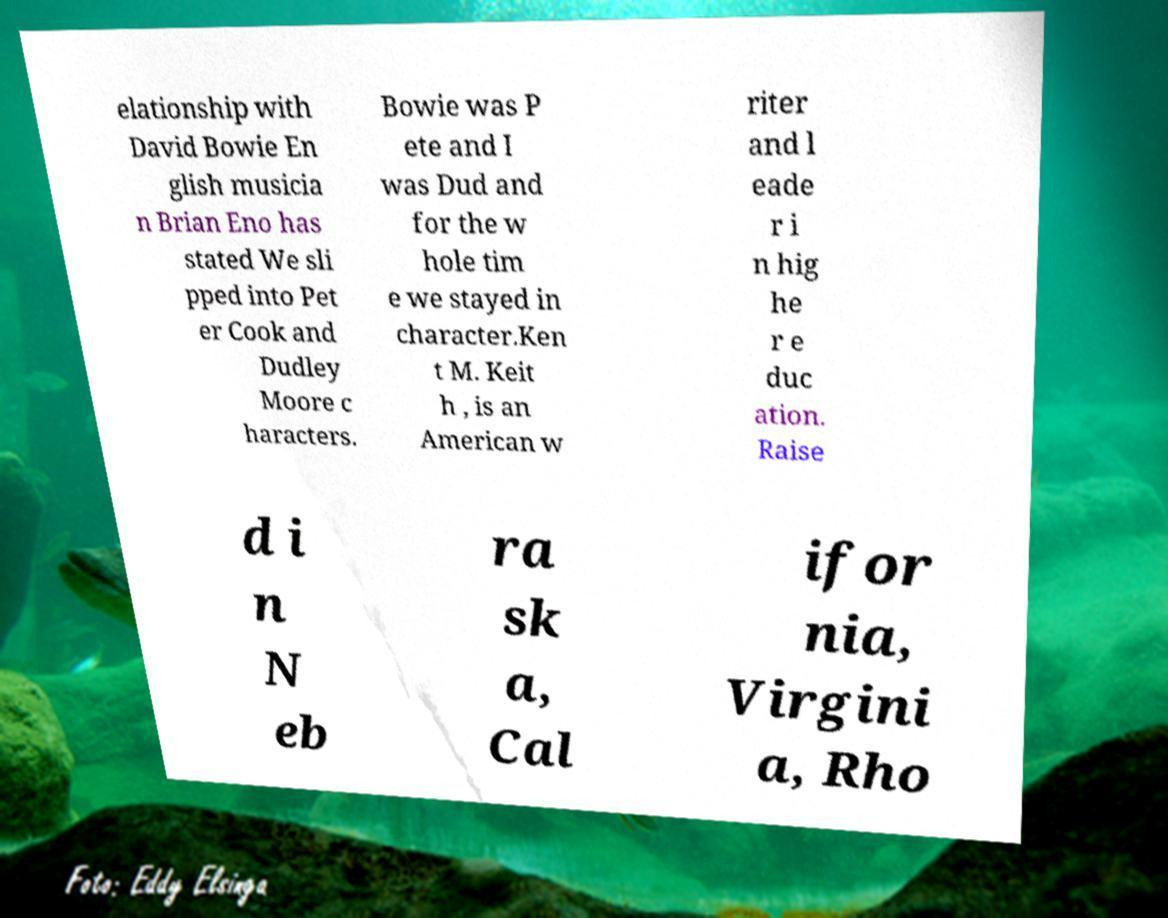Could you extract and type out the text from this image? elationship with David Bowie En glish musicia n Brian Eno has stated We sli pped into Pet er Cook and Dudley Moore c haracters. Bowie was P ete and I was Dud and for the w hole tim e we stayed in character.Ken t M. Keit h , is an American w riter and l eade r i n hig he r e duc ation. Raise d i n N eb ra sk a, Cal ifor nia, Virgini a, Rho 